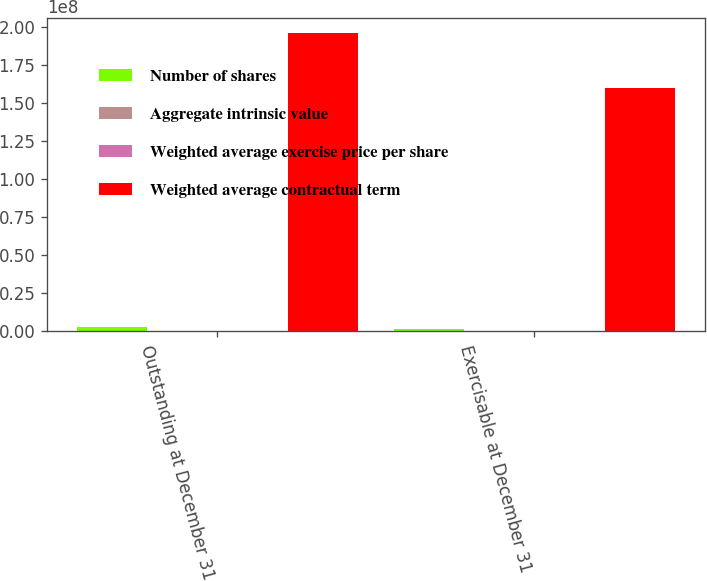<chart> <loc_0><loc_0><loc_500><loc_500><stacked_bar_chart><ecel><fcel>Outstanding at December 31<fcel>Exercisable at December 31<nl><fcel>Number of shares<fcel>2.98111e+06<fcel>1.81124e+06<nl><fcel>Aggregate intrinsic value<fcel>90.48<fcel>68.02<nl><fcel>Weighted average exercise price per share<fcel>6.37<fcel>4.91<nl><fcel>Weighted average contractual term<fcel>1.96378e+08<fcel>1.59978e+08<nl></chart> 